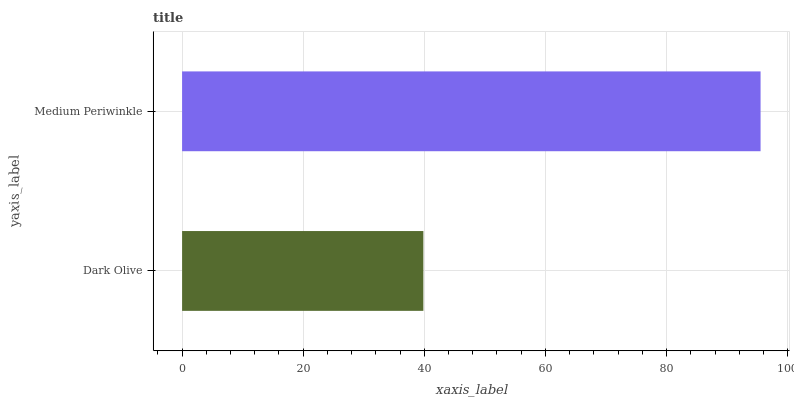Is Dark Olive the minimum?
Answer yes or no. Yes. Is Medium Periwinkle the maximum?
Answer yes or no. Yes. Is Medium Periwinkle the minimum?
Answer yes or no. No. Is Medium Periwinkle greater than Dark Olive?
Answer yes or no. Yes. Is Dark Olive less than Medium Periwinkle?
Answer yes or no. Yes. Is Dark Olive greater than Medium Periwinkle?
Answer yes or no. No. Is Medium Periwinkle less than Dark Olive?
Answer yes or no. No. Is Medium Periwinkle the high median?
Answer yes or no. Yes. Is Dark Olive the low median?
Answer yes or no. Yes. Is Dark Olive the high median?
Answer yes or no. No. Is Medium Periwinkle the low median?
Answer yes or no. No. 